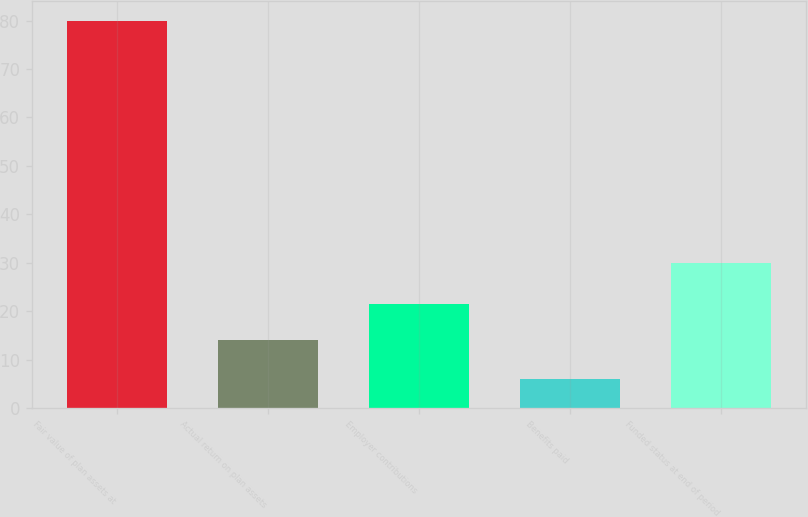Convert chart to OTSL. <chart><loc_0><loc_0><loc_500><loc_500><bar_chart><fcel>Fair value of plan assets at<fcel>Actual return on plan assets<fcel>Employer contributions<fcel>Benefits paid<fcel>Funded status at end of period<nl><fcel>80<fcel>14<fcel>21.4<fcel>6<fcel>30<nl></chart> 